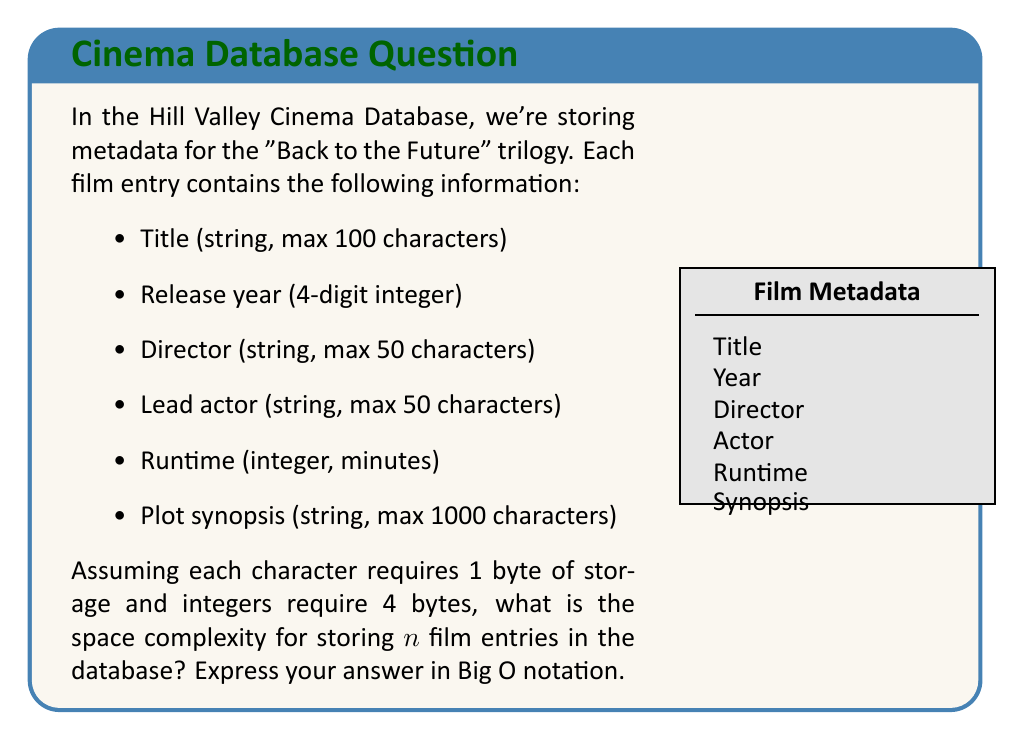Help me with this question. Let's break down the space required for each film entry:

1. Title: max 100 characters = 100 bytes
2. Release year: 1 integer = 4 bytes
3. Director: max 50 characters = 50 bytes
4. Lead actor: max 50 characters = 50 bytes
5. Runtime: 1 integer = 4 bytes
6. Plot synopsis: max 1000 characters = 1000 bytes

Total space for one film entry:
$$ S = 100 + 4 + 50 + 50 + 4 + 1000 = 1208 \text{ bytes} $$

For $n$ film entries, the total space required would be:
$$ T(n) = 1208n \text{ bytes} $$

In Big O notation, we ignore constant factors and focus on the growth rate with respect to $n$. Therefore, the space complexity is linear in terms of the number of film entries, which is expressed as $O(n)$.

This means that as the number of film entries increases, the space required grows linearly. The constant factor (1208 in this case) doesn't affect the Big O notation, as it's concerned with the asymptotic behavior for large values of $n$.
Answer: $O(n)$ 